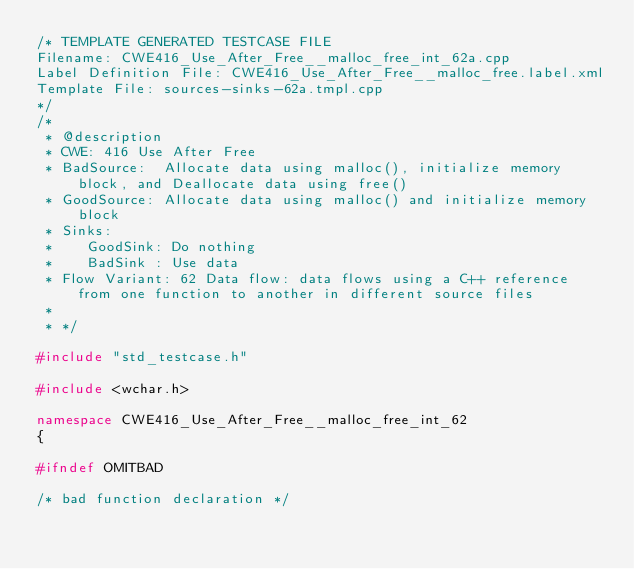<code> <loc_0><loc_0><loc_500><loc_500><_C++_>/* TEMPLATE GENERATED TESTCASE FILE
Filename: CWE416_Use_After_Free__malloc_free_int_62a.cpp
Label Definition File: CWE416_Use_After_Free__malloc_free.label.xml
Template File: sources-sinks-62a.tmpl.cpp
*/
/*
 * @description
 * CWE: 416 Use After Free
 * BadSource:  Allocate data using malloc(), initialize memory block, and Deallocate data using free()
 * GoodSource: Allocate data using malloc() and initialize memory block
 * Sinks:
 *    GoodSink: Do nothing
 *    BadSink : Use data
 * Flow Variant: 62 Data flow: data flows using a C++ reference from one function to another in different source files
 *
 * */

#include "std_testcase.h"

#include <wchar.h>

namespace CWE416_Use_After_Free__malloc_free_int_62
{

#ifndef OMITBAD

/* bad function declaration */</code> 